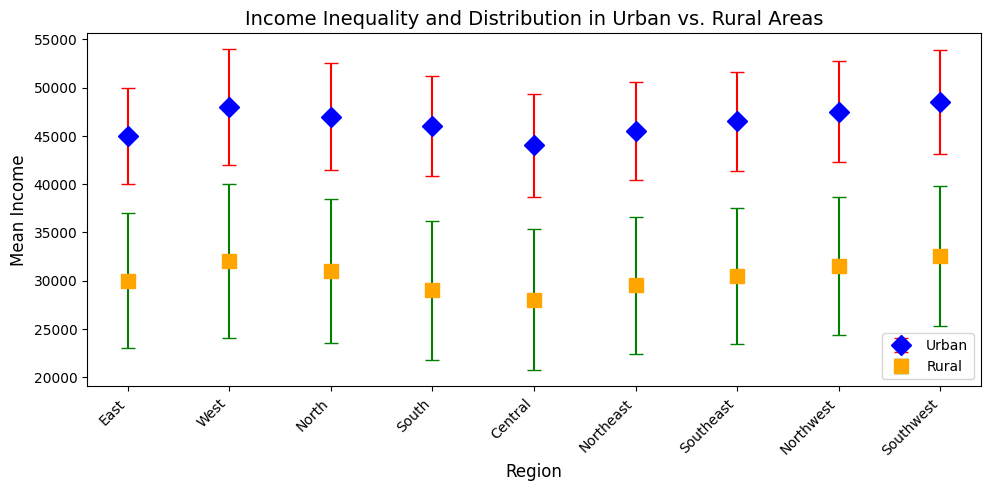What is the difference in mean income between urban and rural areas in the West region? In the West region, the mean income for urban areas is listed as 48,000, while for rural areas it is 32,000. The difference can be calculated as 48,000 - 32,000 = 16,000.
Answer: 16,000 Which region has the highest mean urban income, and what is its value? To find the region with the highest mean urban income, observe each region's mean income for urban areas. The Southwest region has the highest mean urban income, which is 48,500.
Answer: Southwest, 48,500 Which region shows the greatest income disparity between urban and rural areas? To determine the region with the greatest income disparity, calculate the difference between urban and rural mean incomes for each region. The East region shows an income disparity of 45,000 - 30,000 = 15,000, which is the highest among all regions.
Answer: East How does the mean rural income in the Central region compare to the mean urban income in the Northeast region? The mean rural income in the Central region is 28,000, while the mean urban income in the Northeast region is 45,500. Comparing the two, 28,000 < 45,500, showing that the mean income in Central rural areas is significantly lower than in Northeast urban areas.
Answer: Lower What is the average mean income for urban areas across all regions? To calculate the average mean income for urban areas, sum the mean incomes and divide by the number of regions: (45,000 + 48,000 + 47,000 + 46,000 + 44,000 + 45,500 + 46,500 + 47,500 + 48,500) / 9 = 46,833.33.
Answer: 46,833.33 Which area type (urban or rural) exhibits higher variability in income, and how do you know? Compare the standard deviations listed for urban and rural areas across all regions. The rural areas consistently have higher standard deviations (ranging from 7,000 to 8,000) compared to urban areas (ranging from 5,000 to 6,000). Therefore, rural areas exhibit higher variability in income.
Answer: Rural Is there any region where the mean rural income is higher than any other region's mean urban income? To evaluate this, compare the highest mean rural income (32,500 in the Southwest) against the lowest mean urban income (44,000 in Central). Since 32,500 < 44,000, there is no region where the mean rural income is higher than any urban income.
Answer: No 